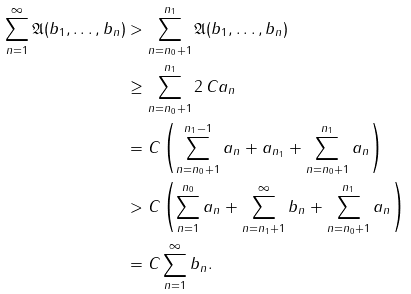<formula> <loc_0><loc_0><loc_500><loc_500>\sum _ { n = 1 } ^ { \infty } \mathfrak { A } ( b _ { 1 } , \dots , b _ { n } ) & > \sum _ { n = n _ { 0 } + 1 } ^ { n _ { 1 } } \mathfrak { A } ( b _ { 1 } , \dots , b _ { n } ) \\ & \geq \sum _ { n = n _ { 0 } + 1 } ^ { n _ { 1 } } 2 \, C a _ { n } \\ & = C \left ( \sum _ { n = n _ { 0 } + 1 } ^ { n _ { 1 } - 1 } a _ { n } + a _ { n _ { 1 } } + \sum _ { n = n _ { 0 } + 1 } ^ { n _ { 1 } } a _ { n } \right ) \\ & > C \left ( \sum _ { n = 1 } ^ { n _ { 0 } } a _ { n } + \sum _ { n = n _ { 1 } + 1 } ^ { \infty } b _ { n } + \sum _ { n = n _ { 0 } + 1 } ^ { n _ { 1 } } a _ { n } \right ) \\ & = C \sum _ { n = 1 } ^ { \infty } b _ { n } .</formula> 